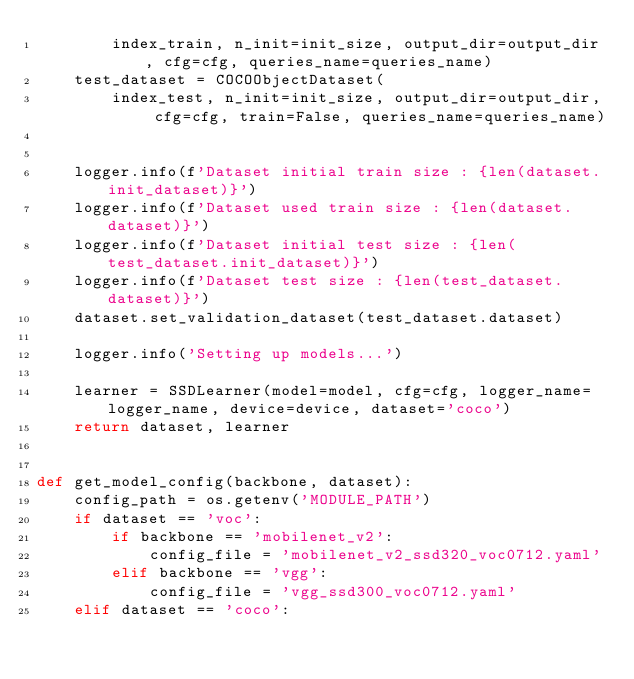Convert code to text. <code><loc_0><loc_0><loc_500><loc_500><_Python_>        index_train, n_init=init_size, output_dir=output_dir, cfg=cfg, queries_name=queries_name)
    test_dataset = COCOObjectDataset(
        index_test, n_init=init_size, output_dir=output_dir, cfg=cfg, train=False, queries_name=queries_name)
    

    logger.info(f'Dataset initial train size : {len(dataset.init_dataset)}')
    logger.info(f'Dataset used train size : {len(dataset.dataset)}')
    logger.info(f'Dataset initial test size : {len(test_dataset.init_dataset)}')
    logger.info(f'Dataset test size : {len(test_dataset.dataset)}')
    dataset.set_validation_dataset(test_dataset.dataset)

    logger.info('Setting up models...')

    learner = SSDLearner(model=model, cfg=cfg, logger_name=logger_name, device=device, dataset='coco')
    return dataset, learner


def get_model_config(backbone, dataset):
    config_path = os.getenv('MODULE_PATH')
    if dataset == 'voc':
        if backbone == 'mobilenet_v2':
            config_file = 'mobilenet_v2_ssd320_voc0712.yaml'
        elif backbone == 'vgg':
            config_file = 'vgg_ssd300_voc0712.yaml'
    elif dataset == 'coco':</code> 